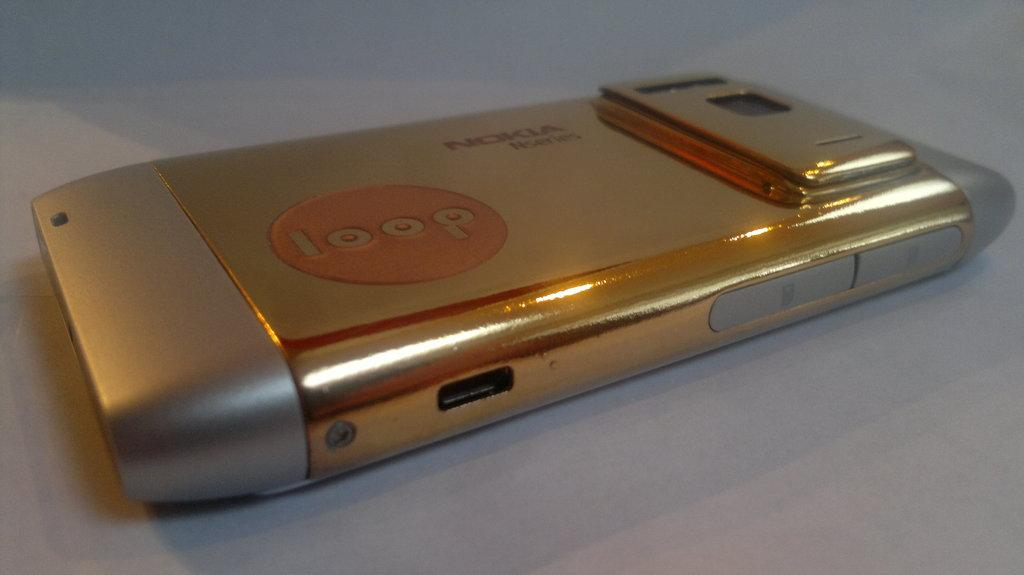Provide a one-sentence caption for the provided image. A Nokia camera that says loop on the front. 